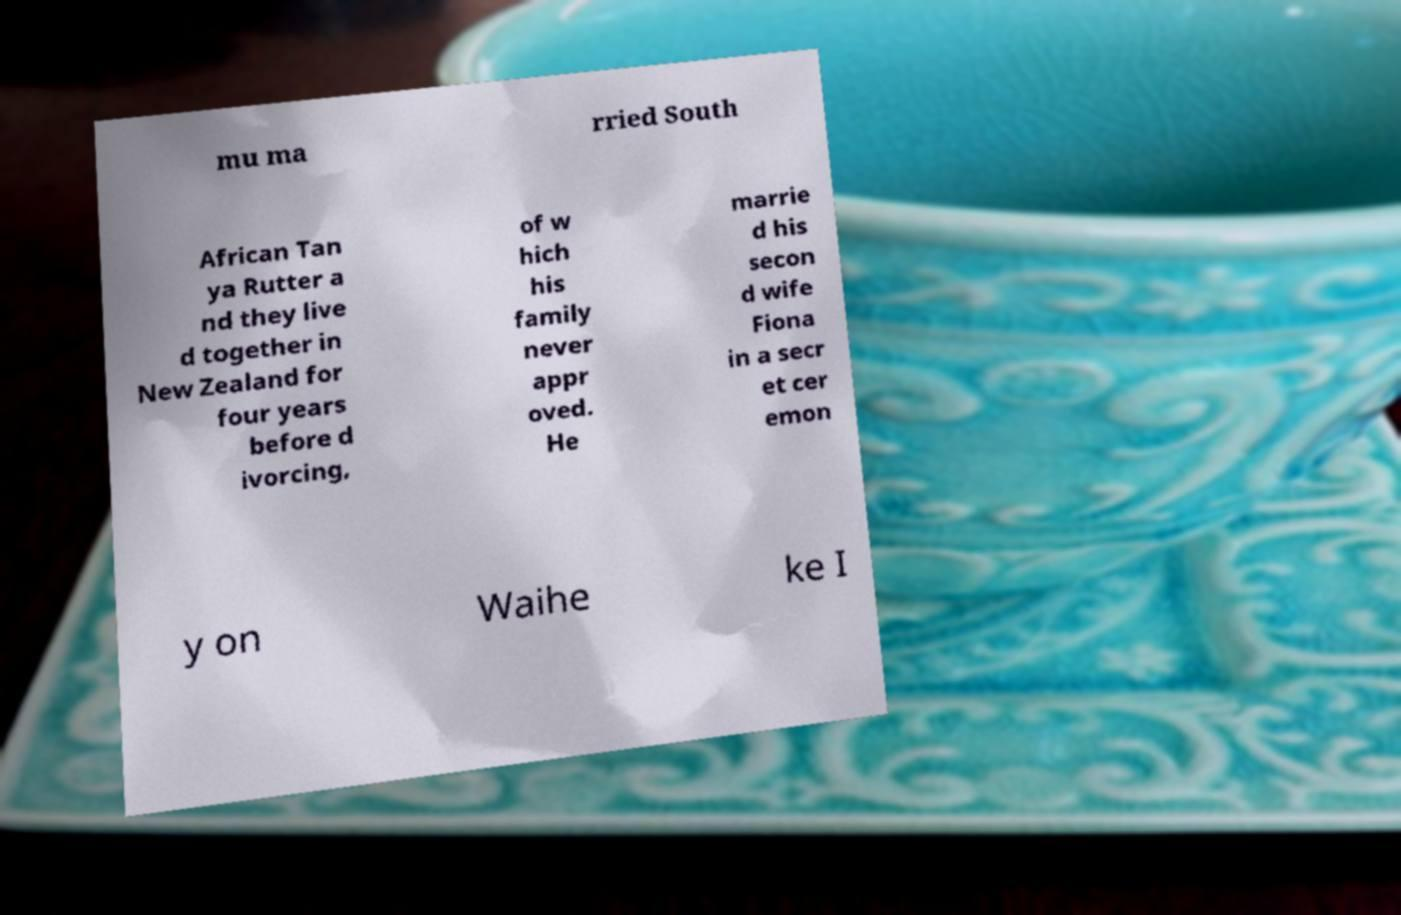I need the written content from this picture converted into text. Can you do that? mu ma rried South African Tan ya Rutter a nd they live d together in New Zealand for four years before d ivorcing, of w hich his family never appr oved. He marrie d his secon d wife Fiona in a secr et cer emon y on Waihe ke I 